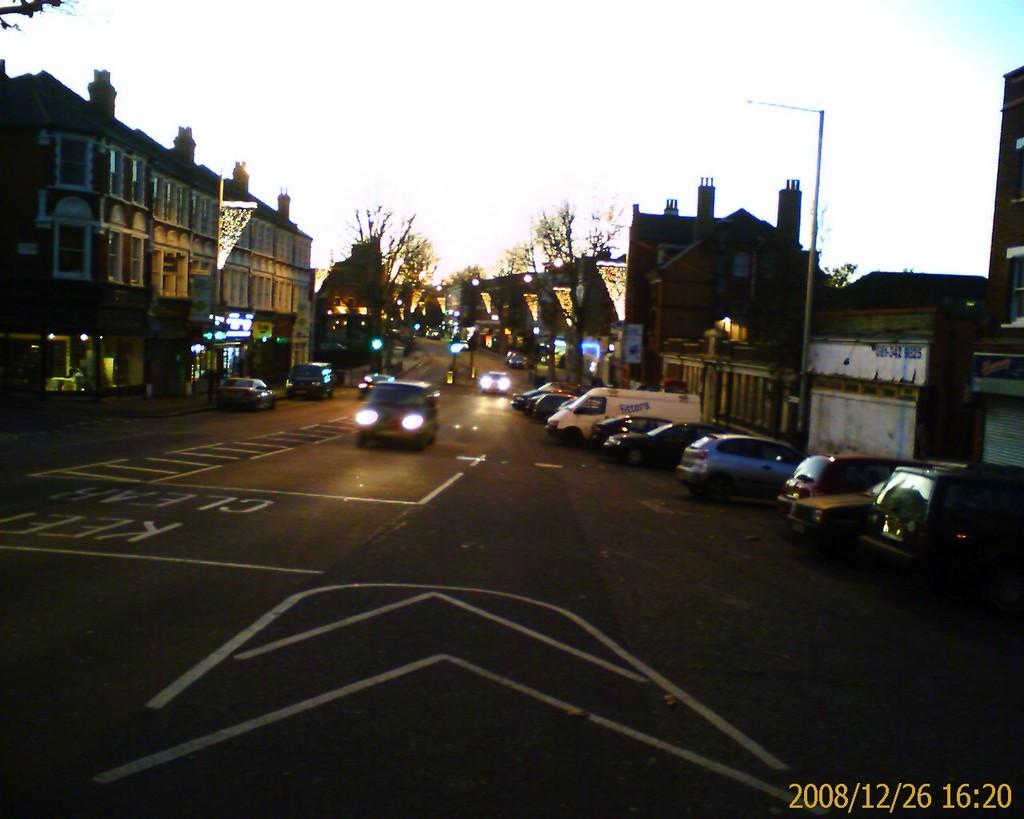What type of structures can be seen in the image? There are buildings in the image. What feature can be observed on the buildings? There are windows visible in the image. What type of natural elements are present in the image? There are trees in the image. What type of artificial light sources are visible in the image? There are lights in the image. What type of transportation is present in the image? There are vehicles on the road in the image. What is the color of the sky in the image? The sky is blue and white in color. Can you tell me how many feet are visible in the image? There are no feet visible in the image; it primarily features buildings, windows, trees, lights, vehicles, and the sky. What type of teaching is being conducted in the image? There is no teaching activity depicted in the image. 